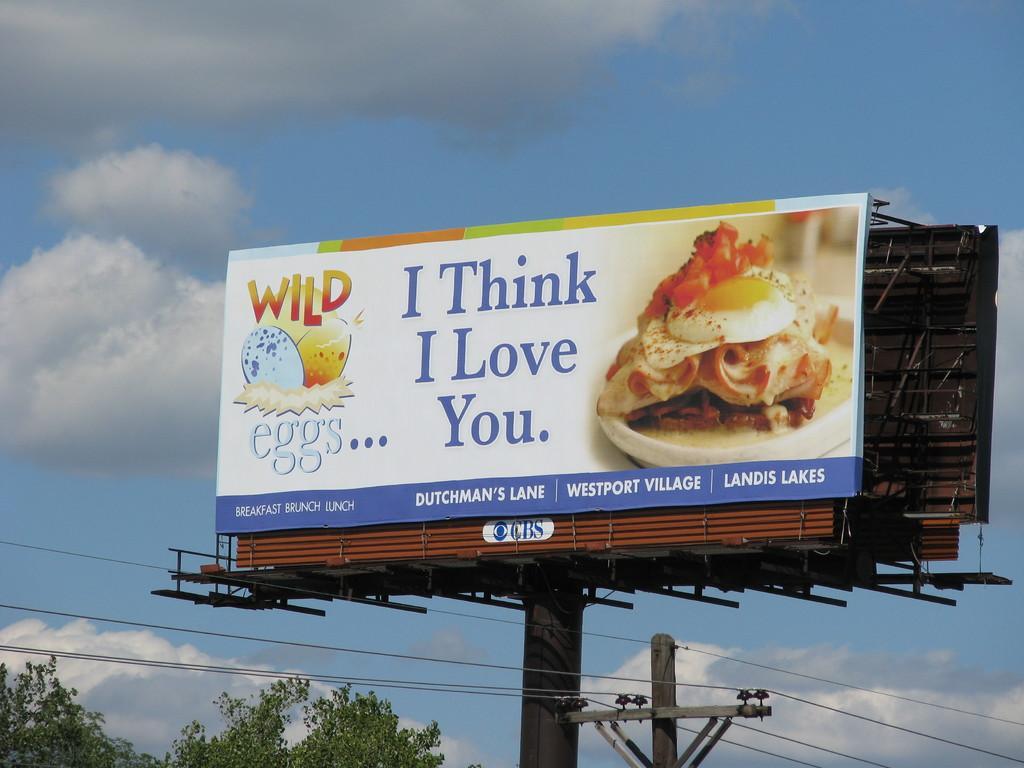Please provide a concise description of this image. In this image, we can see a few poles. We can see some boards with text and images. We can see some wires. There are a few trees at the bottom. We can also see the sky with clouds. 